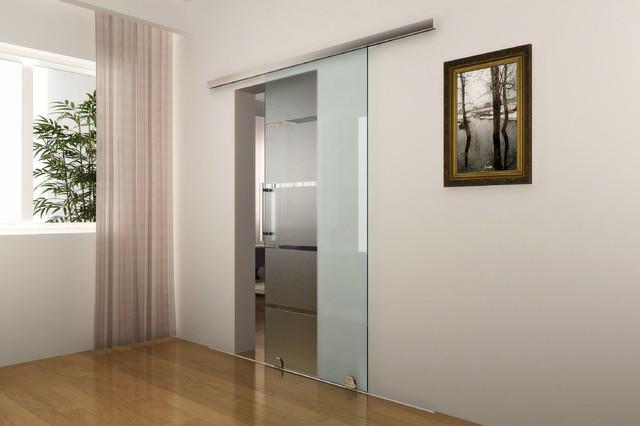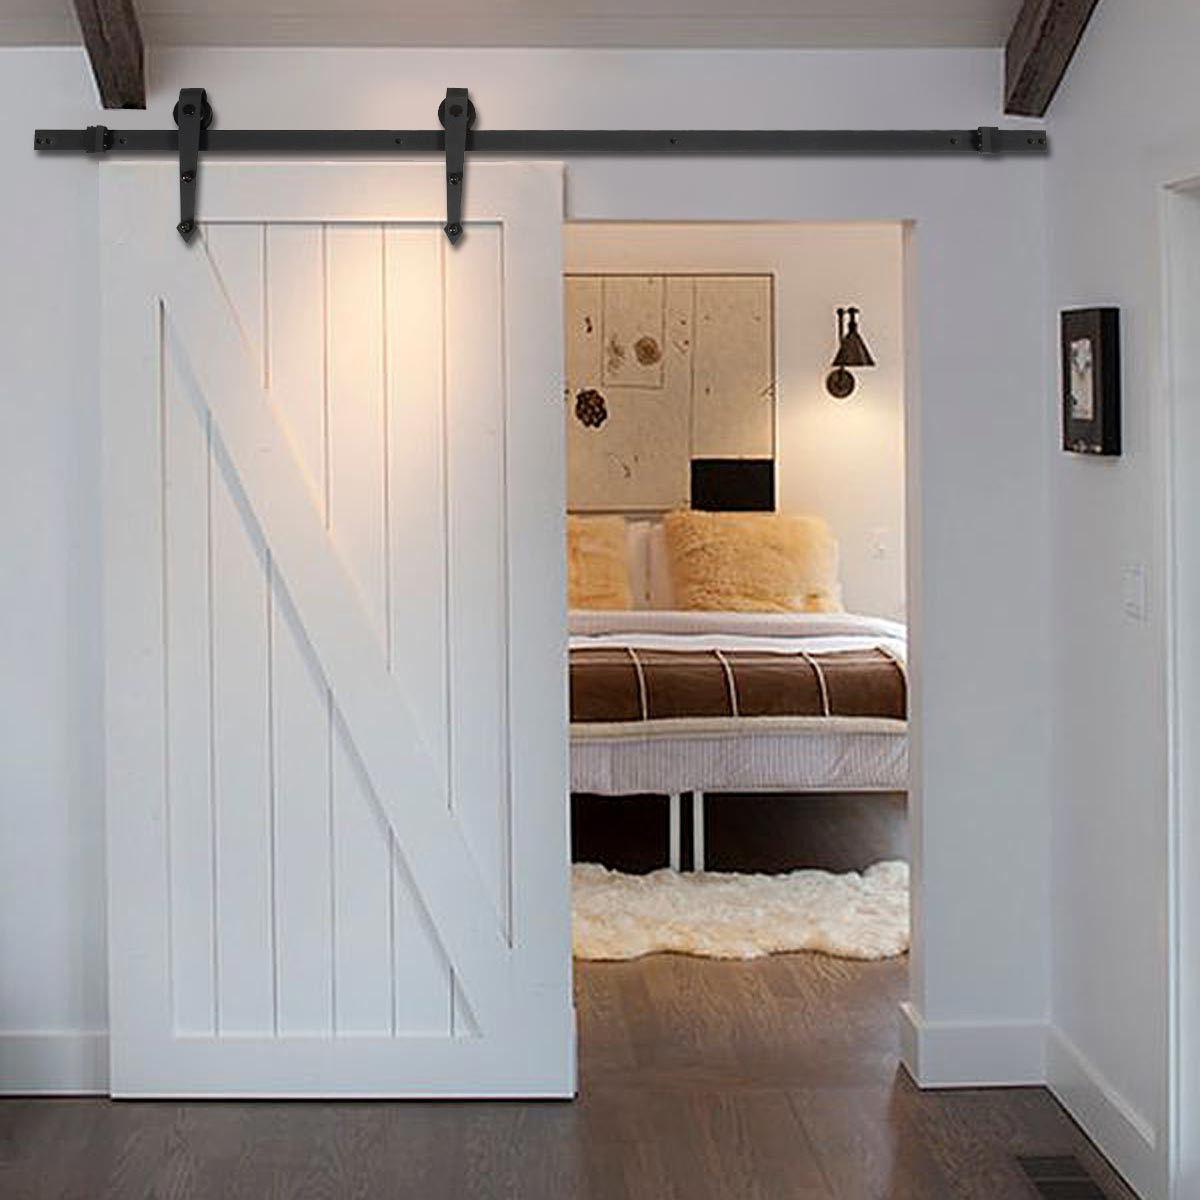The first image is the image on the left, the second image is the image on the right. Evaluate the accuracy of this statement regarding the images: "The left image features a 'barn style' door made of weathered-look horizontal wood boards that slides on a black bar at the top.". Is it true? Answer yes or no. No. 